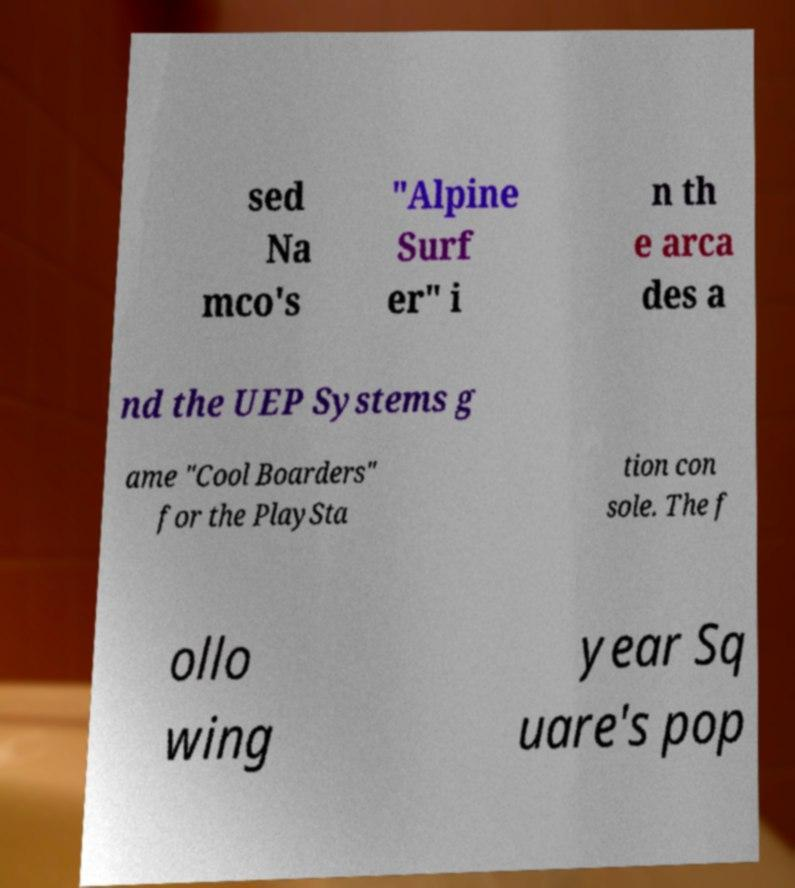Can you read and provide the text displayed in the image?This photo seems to have some interesting text. Can you extract and type it out for me? sed Na mco's "Alpine Surf er" i n th e arca des a nd the UEP Systems g ame "Cool Boarders" for the PlaySta tion con sole. The f ollo wing year Sq uare's pop 